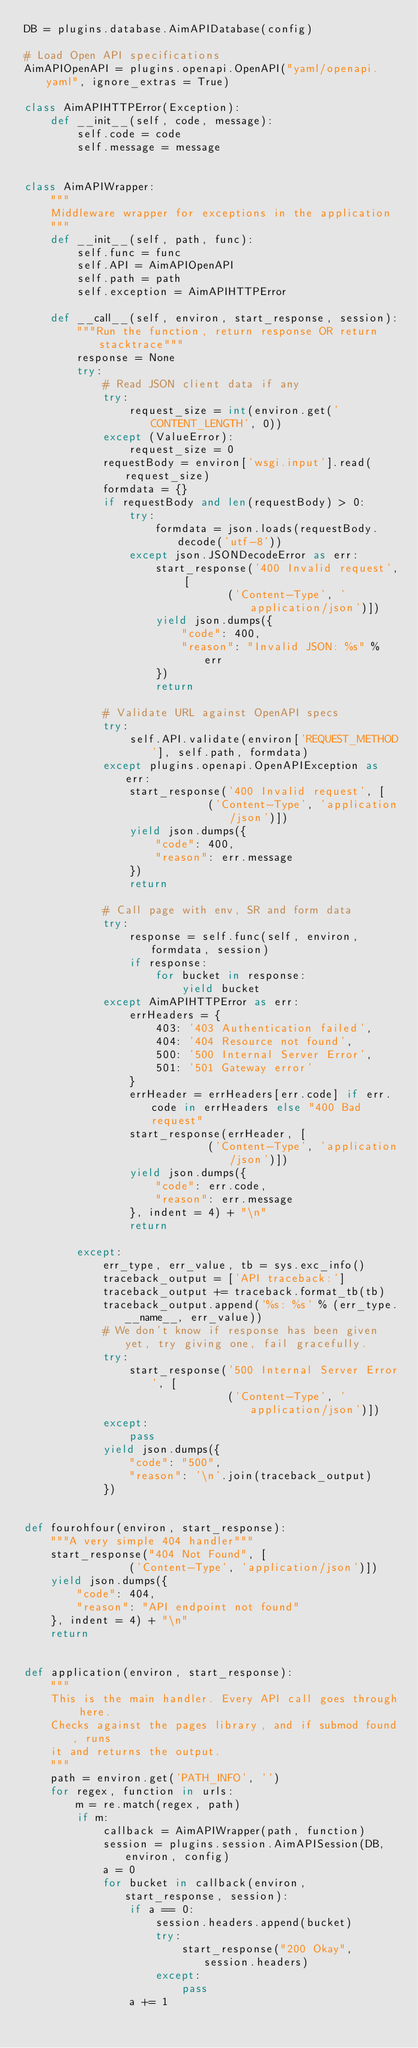Convert code to text. <code><loc_0><loc_0><loc_500><loc_500><_Python_>DB = plugins.database.AimAPIDatabase(config)

# Load Open API specifications
AimAPIOpenAPI = plugins.openapi.OpenAPI("yaml/openapi.yaml", ignore_extras = True)

class AimAPIHTTPError(Exception):
    def __init__(self, code, message):
        self.code = code
        self.message = message
        

class AimAPIWrapper:
    """
    Middleware wrapper for exceptions in the application
    """
    def __init__(self, path, func):
        self.func = func
        self.API = AimAPIOpenAPI
        self.path = path
        self.exception = AimAPIHTTPError
     
    def __call__(self, environ, start_response, session):
        """Run the function, return response OR return stacktrace"""
        response = None
        try:
            # Read JSON client data if any
            try:
                request_size = int(environ.get('CONTENT_LENGTH', 0))
            except (ValueError):
                request_size = 0
            requestBody = environ['wsgi.input'].read(request_size)
            formdata = {}
            if requestBody and len(requestBody) > 0:
                try:
                    formdata = json.loads(requestBody.decode('utf-8'))
                except json.JSONDecodeError as err:
                    start_response('400 Invalid request', [
                               ('Content-Type', 'application/json')])
                    yield json.dumps({
                        "code": 400,
                        "reason": "Invalid JSON: %s" % err
                    })
                    return
                
            # Validate URL against OpenAPI specs
            try:
                self.API.validate(environ['REQUEST_METHOD'], self.path, formdata)
            except plugins.openapi.OpenAPIException as err:
                start_response('400 Invalid request', [
                            ('Content-Type', 'application/json')])
                yield json.dumps({
                    "code": 400,
                    "reason": err.message
                })
                return
            
            # Call page with env, SR and form data
            try:
                response = self.func(self, environ, formdata, session)
                if response:
                    for bucket in response:
                        yield bucket
            except AimAPIHTTPError as err:
                errHeaders = {
                    403: '403 Authentication failed',
                    404: '404 Resource not found',
                    500: '500 Internal Server Error',
                    501: '501 Gateway error'
                }
                errHeader = errHeaders[err.code] if err.code in errHeaders else "400 Bad request"
                start_response(errHeader, [
                            ('Content-Type', 'application/json')])
                yield json.dumps({
                    "code": err.code,
                    "reason": err.message
                }, indent = 4) + "\n"
                return
            
        except:
            err_type, err_value, tb = sys.exc_info()
            traceback_output = ['API traceback:']
            traceback_output += traceback.format_tb(tb)
            traceback_output.append('%s: %s' % (err_type.__name__, err_value))
            # We don't know if response has been given yet, try giving one, fail gracefully.
            try:
                start_response('500 Internal Server Error', [
                               ('Content-Type', 'application/json')])
            except:
                pass
            yield json.dumps({
                "code": "500",
                "reason": '\n'.join(traceback_output)
            })
    
        
def fourohfour(environ, start_response):
    """A very simple 404 handler"""
    start_response("404 Not Found", [
                ('Content-Type', 'application/json')])
    yield json.dumps({
        "code": 404,
        "reason": "API endpoint not found"
    }, indent = 4) + "\n"
    return


def application(environ, start_response):
    """
    This is the main handler. Every API call goes through here.
    Checks against the pages library, and if submod found, runs
    it and returns the output.
    """
    path = environ.get('PATH_INFO', '')
    for regex, function in urls:
        m = re.match(regex, path)
        if m:
            callback = AimAPIWrapper(path, function)
            session = plugins.session.AimAPISession(DB, environ, config)
            a = 0
            for bucket in callback(environ, start_response, session):
                if a == 0:
                    session.headers.append(bucket)
                    try:
                        start_response("200 Okay", session.headers)
                    except:
                        pass
                a += 1</code> 